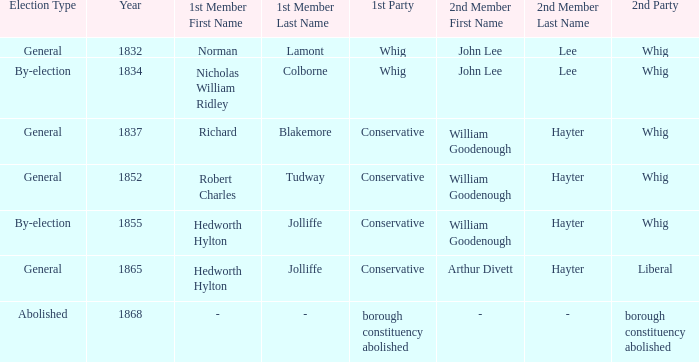Who's the conservative 1st member of the election of 1852? Robert Charles Tudway. 